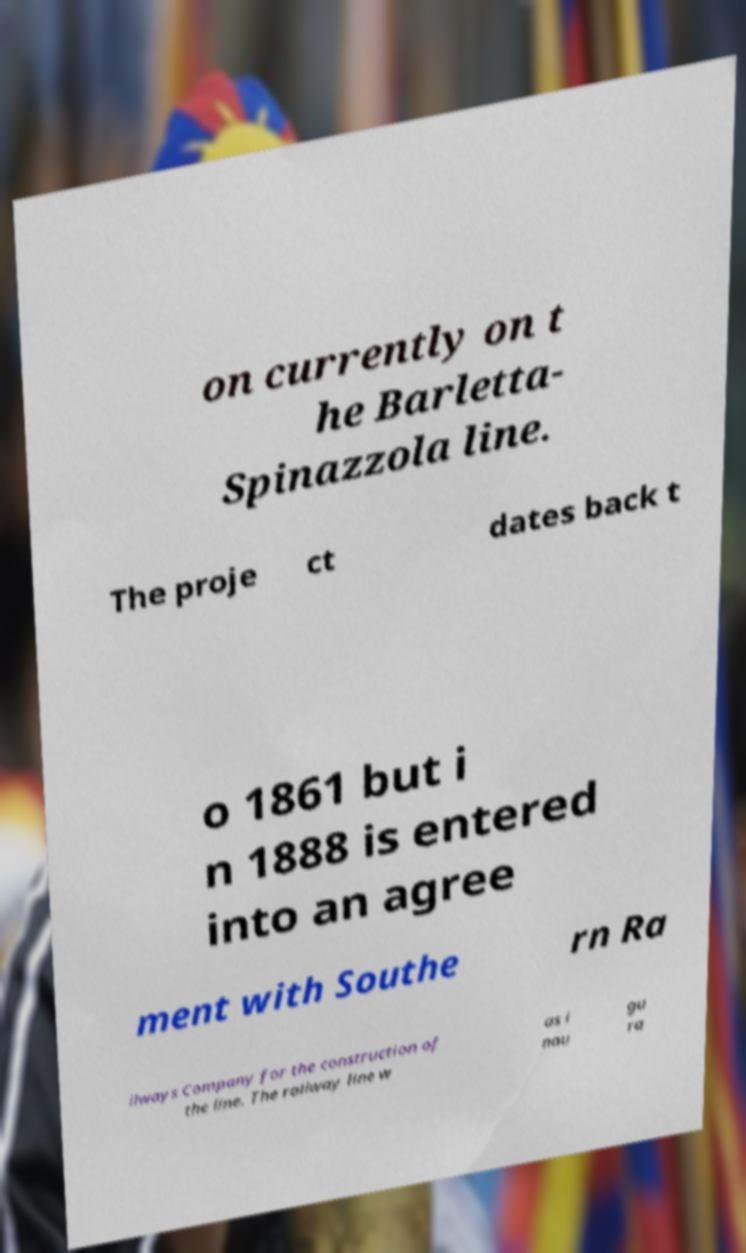There's text embedded in this image that I need extracted. Can you transcribe it verbatim? on currently on t he Barletta- Spinazzola line. The proje ct dates back t o 1861 but i n 1888 is entered into an agree ment with Southe rn Ra ilways Company for the construction of the line. The railway line w as i nau gu ra 